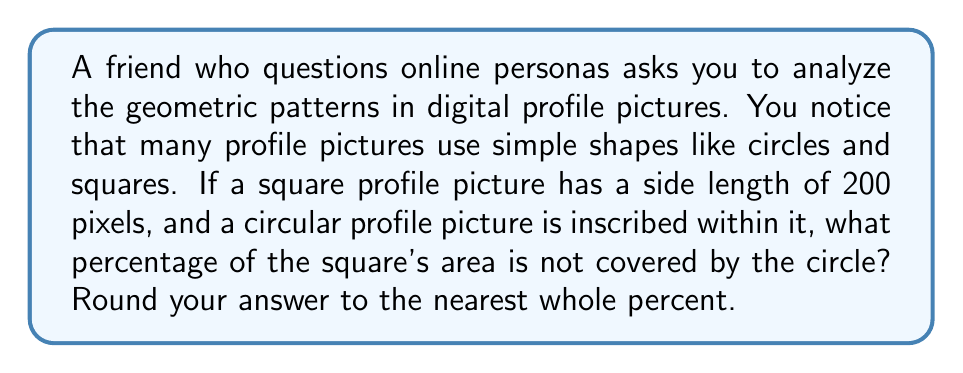Could you help me with this problem? Let's approach this step-by-step:

1) The area of a square is given by the formula:
   $$A_s = s^2$$
   where $s$ is the side length.

2) The area of a circle is given by the formula:
   $$A_c = \pi r^2$$
   where $r$ is the radius.

3) In this case, the circle is inscribed in the square, so the diameter of the circle equals the side length of the square. Therefore, the radius of the circle is half the side length of the square.

4) Given:
   - Side length of square: $s = 200$ pixels
   - Radius of circle: $r = \frac{s}{2} = 100$ pixels

5) Calculate the area of the square:
   $$A_s = 200^2 = 40,000 \text{ square pixels}$$

6) Calculate the area of the circle:
   $$A_c = \pi (100)^2 = 10,000\pi \approx 31,416 \text{ square pixels}$$

7) The area not covered by the circle is:
   $$A_{\text{not covered}} = A_s - A_c = 40,000 - 31,416 = 8,584 \text{ square pixels}$$

8) To express this as a percentage of the square's area:
   $$\text{Percentage} = \frac{A_{\text{not covered}}}{A_s} \times 100\% = \frac{8,584}{40,000} \times 100\% \approx 21.46\%$$

9) Rounding to the nearest whole percent gives us 21%.
Answer: 21% 